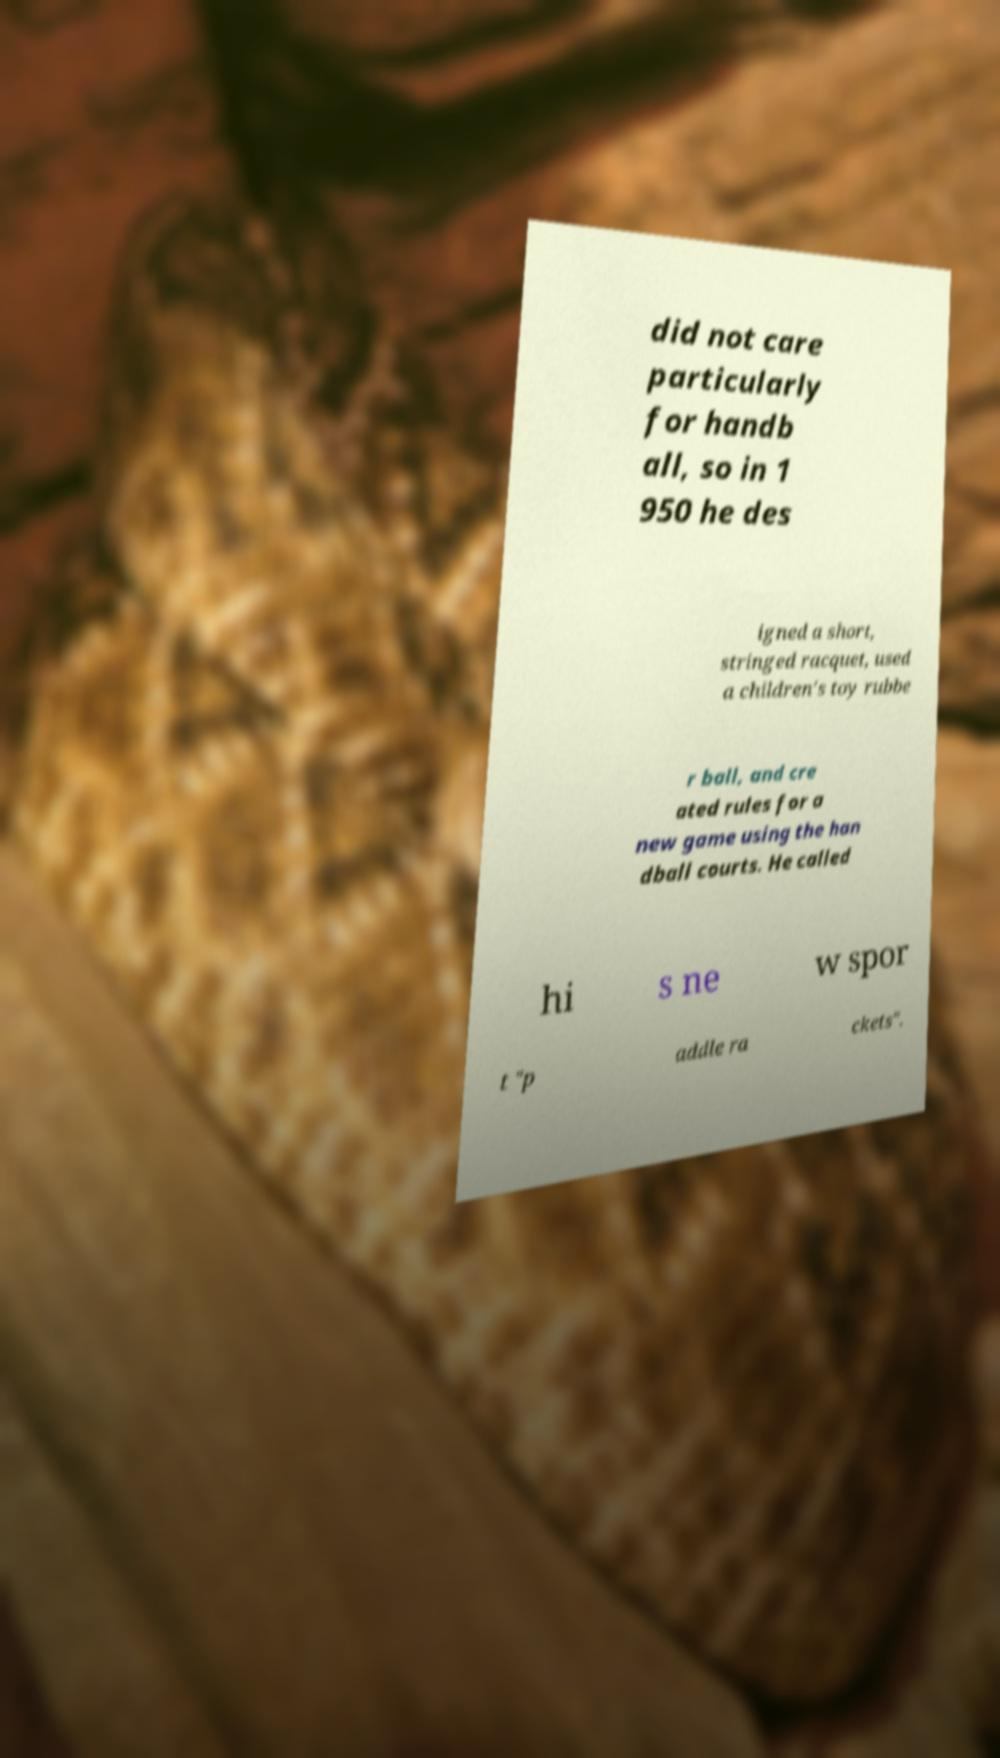Please read and relay the text visible in this image. What does it say? did not care particularly for handb all, so in 1 950 he des igned a short, stringed racquet, used a children's toy rubbe r ball, and cre ated rules for a new game using the han dball courts. He called hi s ne w spor t "p addle ra ckets". 